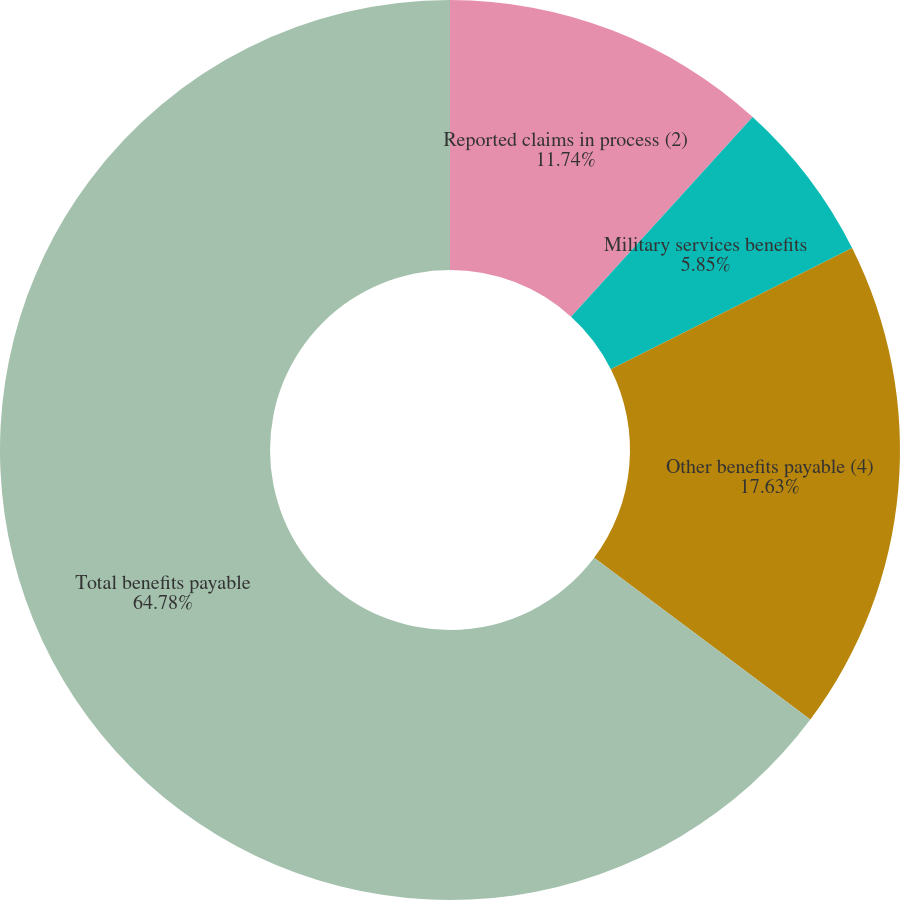Convert chart to OTSL. <chart><loc_0><loc_0><loc_500><loc_500><pie_chart><fcel>Reported claims in process (2)<fcel>Military services benefits<fcel>Other benefits payable (4)<fcel>Total benefits payable<nl><fcel>11.74%<fcel>5.85%<fcel>17.63%<fcel>64.77%<nl></chart> 